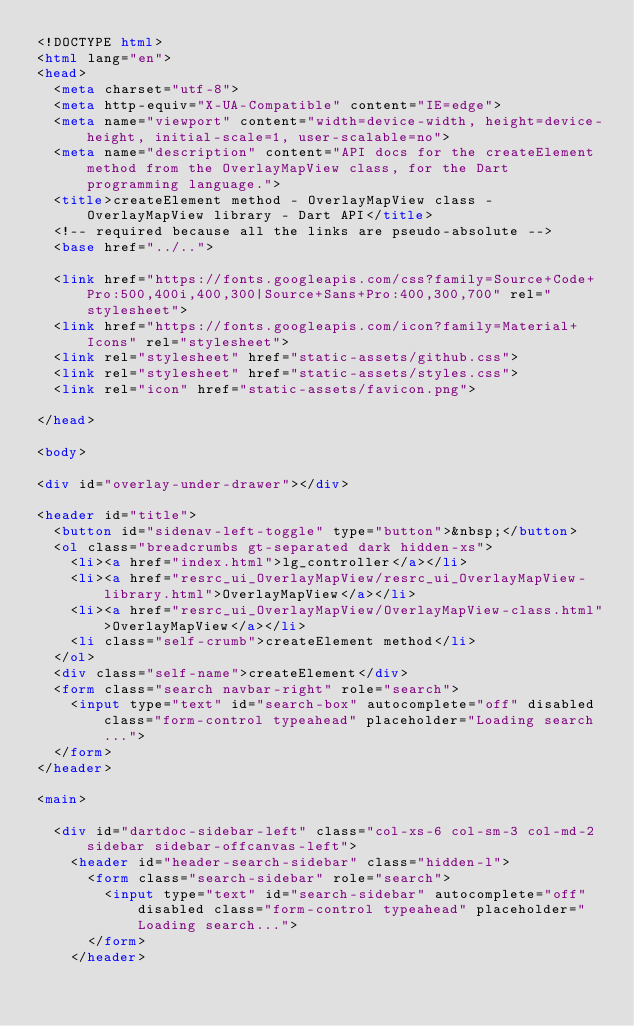<code> <loc_0><loc_0><loc_500><loc_500><_HTML_><!DOCTYPE html>
<html lang="en">
<head>
  <meta charset="utf-8">
  <meta http-equiv="X-UA-Compatible" content="IE=edge">
  <meta name="viewport" content="width=device-width, height=device-height, initial-scale=1, user-scalable=no">
  <meta name="description" content="API docs for the createElement method from the OverlayMapView class, for the Dart programming language.">
  <title>createElement method - OverlayMapView class - OverlayMapView library - Dart API</title>
  <!-- required because all the links are pseudo-absolute -->
  <base href="../..">

  <link href="https://fonts.googleapis.com/css?family=Source+Code+Pro:500,400i,400,300|Source+Sans+Pro:400,300,700" rel="stylesheet">
  <link href="https://fonts.googleapis.com/icon?family=Material+Icons" rel="stylesheet">
  <link rel="stylesheet" href="static-assets/github.css">
  <link rel="stylesheet" href="static-assets/styles.css">
  <link rel="icon" href="static-assets/favicon.png">
  
</head>

<body>

<div id="overlay-under-drawer"></div>

<header id="title">
  <button id="sidenav-left-toggle" type="button">&nbsp;</button>
  <ol class="breadcrumbs gt-separated dark hidden-xs">
    <li><a href="index.html">lg_controller</a></li>
    <li><a href="resrc_ui_OverlayMapView/resrc_ui_OverlayMapView-library.html">OverlayMapView</a></li>
    <li><a href="resrc_ui_OverlayMapView/OverlayMapView-class.html">OverlayMapView</a></li>
    <li class="self-crumb">createElement method</li>
  </ol>
  <div class="self-name">createElement</div>
  <form class="search navbar-right" role="search">
    <input type="text" id="search-box" autocomplete="off" disabled class="form-control typeahead" placeholder="Loading search...">
  </form>
</header>

<main>

  <div id="dartdoc-sidebar-left" class="col-xs-6 col-sm-3 col-md-2 sidebar sidebar-offcanvas-left">
    <header id="header-search-sidebar" class="hidden-l">
      <form class="search-sidebar" role="search">
        <input type="text" id="search-sidebar" autocomplete="off" disabled class="form-control typeahead" placeholder="Loading search...">
      </form>
    </header>
    </code> 